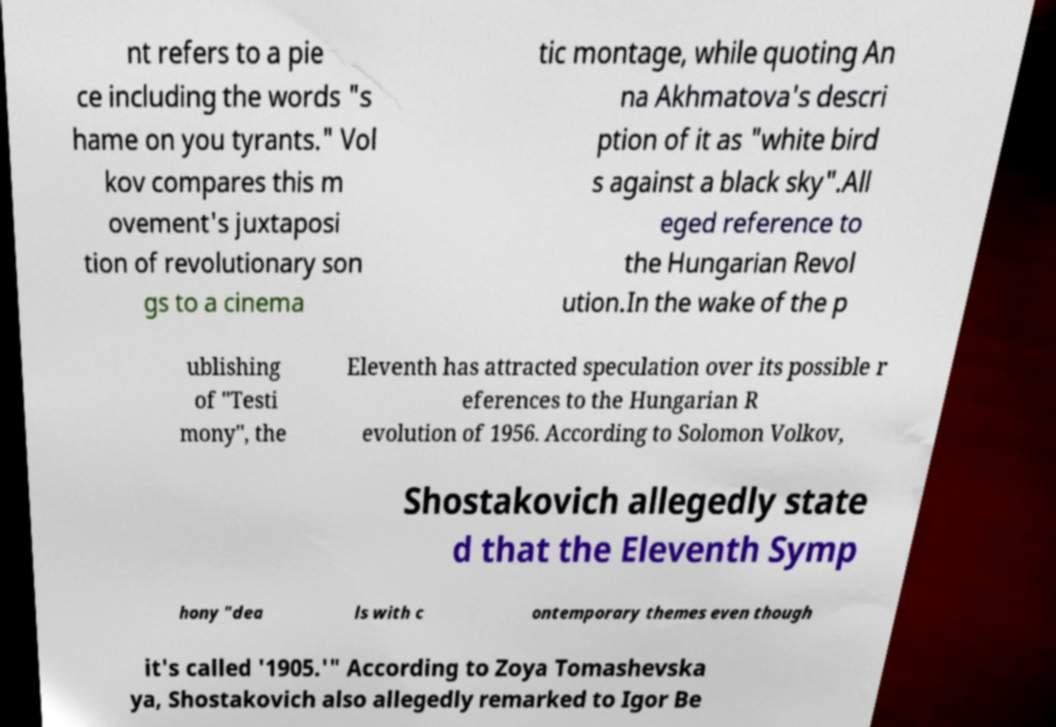Could you extract and type out the text from this image? nt refers to a pie ce including the words "s hame on you tyrants." Vol kov compares this m ovement's juxtaposi tion of revolutionary son gs to a cinema tic montage, while quoting An na Akhmatova's descri ption of it as "white bird s against a black sky".All eged reference to the Hungarian Revol ution.In the wake of the p ublishing of "Testi mony", the Eleventh has attracted speculation over its possible r eferences to the Hungarian R evolution of 1956. According to Solomon Volkov, Shostakovich allegedly state d that the Eleventh Symp hony "dea ls with c ontemporary themes even though it's called '1905.'" According to Zoya Tomashevska ya, Shostakovich also allegedly remarked to Igor Be 